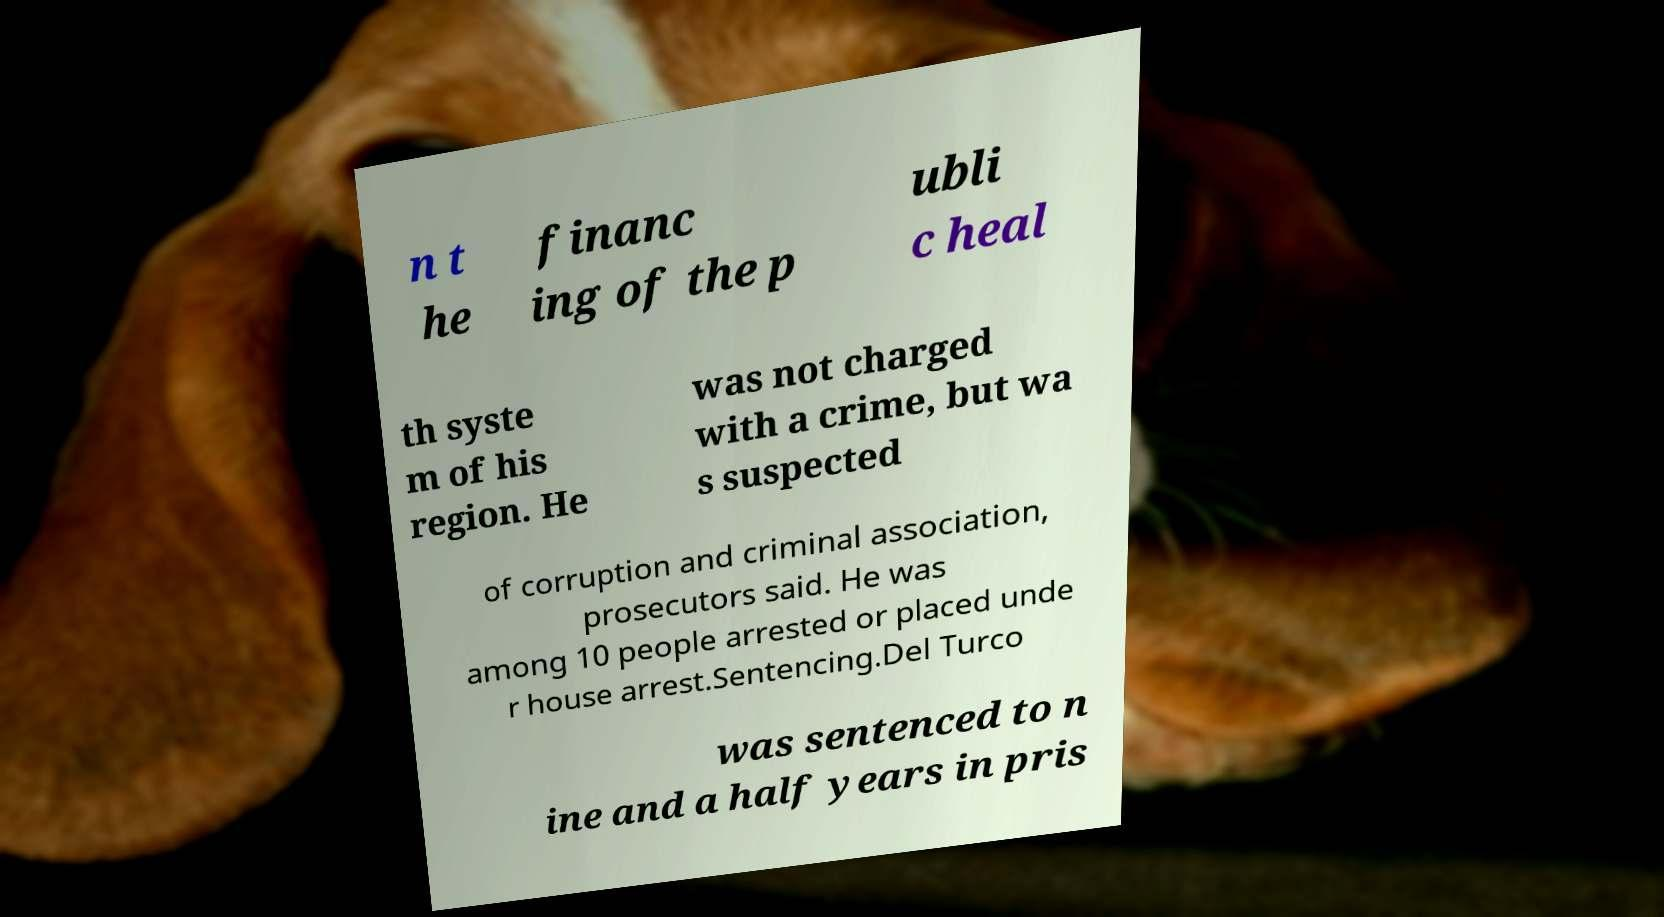I need the written content from this picture converted into text. Can you do that? n t he financ ing of the p ubli c heal th syste m of his region. He was not charged with a crime, but wa s suspected of corruption and criminal association, prosecutors said. He was among 10 people arrested or placed unde r house arrest.Sentencing.Del Turco was sentenced to n ine and a half years in pris 